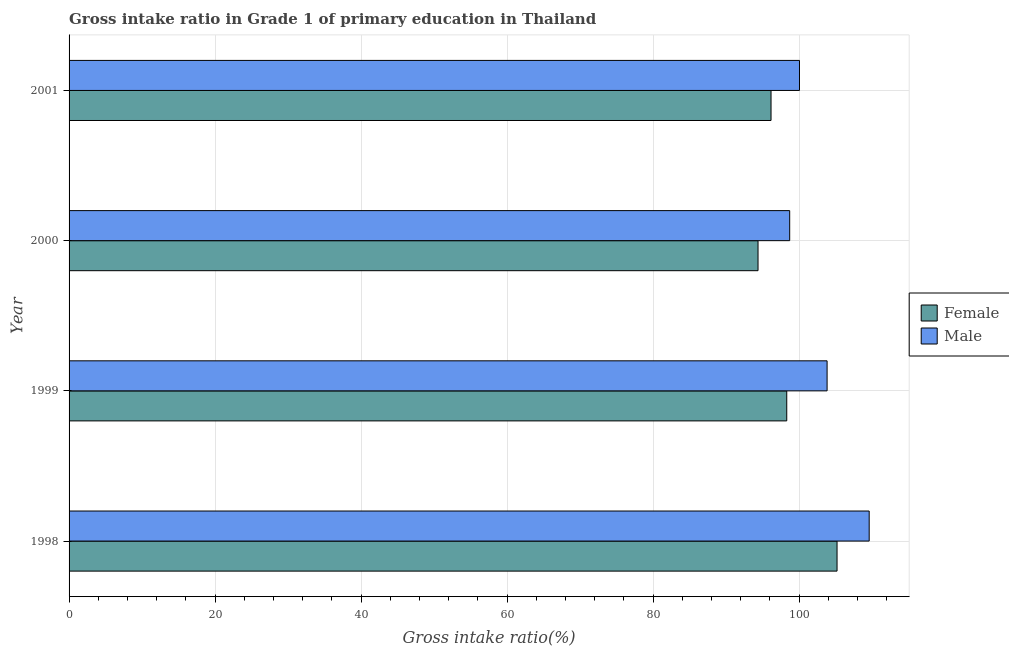How many different coloured bars are there?
Provide a short and direct response. 2. Are the number of bars per tick equal to the number of legend labels?
Your response must be concise. Yes. Are the number of bars on each tick of the Y-axis equal?
Your answer should be compact. Yes. How many bars are there on the 2nd tick from the top?
Provide a succinct answer. 2. What is the label of the 1st group of bars from the top?
Provide a short and direct response. 2001. In how many cases, is the number of bars for a given year not equal to the number of legend labels?
Offer a very short reply. 0. What is the gross intake ratio(female) in 1998?
Provide a short and direct response. 105.2. Across all years, what is the maximum gross intake ratio(male)?
Offer a very short reply. 109.61. Across all years, what is the minimum gross intake ratio(male)?
Provide a succinct answer. 98.71. In which year was the gross intake ratio(female) minimum?
Offer a very short reply. 2000. What is the total gross intake ratio(male) in the graph?
Ensure brevity in your answer.  412.21. What is the difference between the gross intake ratio(male) in 1999 and that in 2001?
Provide a succinct answer. 3.78. What is the difference between the gross intake ratio(male) in 2000 and the gross intake ratio(female) in 1998?
Provide a succinct answer. -6.49. What is the average gross intake ratio(female) per year?
Offer a terse response. 98.51. In the year 1998, what is the difference between the gross intake ratio(female) and gross intake ratio(male)?
Ensure brevity in your answer.  -4.4. In how many years, is the gross intake ratio(male) greater than 80 %?
Your answer should be very brief. 4. What is the ratio of the gross intake ratio(male) in 1999 to that in 2001?
Make the answer very short. 1.04. Is the gross intake ratio(male) in 1998 less than that in 1999?
Offer a very short reply. No. What is the difference between the highest and the second highest gross intake ratio(male)?
Your answer should be compact. 5.77. What is the difference between the highest and the lowest gross intake ratio(female)?
Give a very brief answer. 10.82. In how many years, is the gross intake ratio(male) greater than the average gross intake ratio(male) taken over all years?
Your answer should be very brief. 2. What does the 2nd bar from the top in 2001 represents?
Your answer should be very brief. Female. What does the 2nd bar from the bottom in 2001 represents?
Provide a succinct answer. Male. How many bars are there?
Your answer should be compact. 8. How many years are there in the graph?
Give a very brief answer. 4. Are the values on the major ticks of X-axis written in scientific E-notation?
Keep it short and to the point. No. Does the graph contain grids?
Provide a short and direct response. Yes. How many legend labels are there?
Offer a very short reply. 2. How are the legend labels stacked?
Give a very brief answer. Vertical. What is the title of the graph?
Give a very brief answer. Gross intake ratio in Grade 1 of primary education in Thailand. Does "Largest city" appear as one of the legend labels in the graph?
Offer a very short reply. No. What is the label or title of the X-axis?
Offer a terse response. Gross intake ratio(%). What is the Gross intake ratio(%) in Female in 1998?
Offer a very short reply. 105.2. What is the Gross intake ratio(%) of Male in 1998?
Your response must be concise. 109.61. What is the Gross intake ratio(%) in Female in 1999?
Keep it short and to the point. 98.31. What is the Gross intake ratio(%) in Male in 1999?
Your answer should be compact. 103.84. What is the Gross intake ratio(%) in Female in 2000?
Your answer should be compact. 94.38. What is the Gross intake ratio(%) in Male in 2000?
Make the answer very short. 98.71. What is the Gross intake ratio(%) in Female in 2001?
Offer a very short reply. 96.16. What is the Gross intake ratio(%) in Male in 2001?
Provide a short and direct response. 100.06. Across all years, what is the maximum Gross intake ratio(%) of Female?
Your response must be concise. 105.2. Across all years, what is the maximum Gross intake ratio(%) in Male?
Offer a very short reply. 109.61. Across all years, what is the minimum Gross intake ratio(%) of Female?
Give a very brief answer. 94.38. Across all years, what is the minimum Gross intake ratio(%) in Male?
Keep it short and to the point. 98.71. What is the total Gross intake ratio(%) of Female in the graph?
Provide a succinct answer. 394.05. What is the total Gross intake ratio(%) of Male in the graph?
Give a very brief answer. 412.21. What is the difference between the Gross intake ratio(%) of Female in 1998 and that in 1999?
Make the answer very short. 6.89. What is the difference between the Gross intake ratio(%) in Male in 1998 and that in 1999?
Provide a short and direct response. 5.77. What is the difference between the Gross intake ratio(%) in Female in 1998 and that in 2000?
Offer a very short reply. 10.82. What is the difference between the Gross intake ratio(%) in Male in 1998 and that in 2000?
Offer a very short reply. 10.89. What is the difference between the Gross intake ratio(%) of Female in 1998 and that in 2001?
Give a very brief answer. 9.04. What is the difference between the Gross intake ratio(%) in Male in 1998 and that in 2001?
Make the answer very short. 9.55. What is the difference between the Gross intake ratio(%) in Female in 1999 and that in 2000?
Your response must be concise. 3.93. What is the difference between the Gross intake ratio(%) in Male in 1999 and that in 2000?
Ensure brevity in your answer.  5.12. What is the difference between the Gross intake ratio(%) in Female in 1999 and that in 2001?
Your answer should be very brief. 2.15. What is the difference between the Gross intake ratio(%) in Male in 1999 and that in 2001?
Ensure brevity in your answer.  3.78. What is the difference between the Gross intake ratio(%) of Female in 2000 and that in 2001?
Your response must be concise. -1.78. What is the difference between the Gross intake ratio(%) in Male in 2000 and that in 2001?
Your response must be concise. -1.34. What is the difference between the Gross intake ratio(%) of Female in 1998 and the Gross intake ratio(%) of Male in 1999?
Ensure brevity in your answer.  1.36. What is the difference between the Gross intake ratio(%) of Female in 1998 and the Gross intake ratio(%) of Male in 2000?
Keep it short and to the point. 6.49. What is the difference between the Gross intake ratio(%) in Female in 1998 and the Gross intake ratio(%) in Male in 2001?
Make the answer very short. 5.15. What is the difference between the Gross intake ratio(%) in Female in 1999 and the Gross intake ratio(%) in Male in 2000?
Your answer should be very brief. -0.4. What is the difference between the Gross intake ratio(%) in Female in 1999 and the Gross intake ratio(%) in Male in 2001?
Offer a terse response. -1.74. What is the difference between the Gross intake ratio(%) in Female in 2000 and the Gross intake ratio(%) in Male in 2001?
Ensure brevity in your answer.  -5.68. What is the average Gross intake ratio(%) of Female per year?
Your answer should be compact. 98.51. What is the average Gross intake ratio(%) in Male per year?
Offer a terse response. 103.05. In the year 1998, what is the difference between the Gross intake ratio(%) of Female and Gross intake ratio(%) of Male?
Your answer should be very brief. -4.4. In the year 1999, what is the difference between the Gross intake ratio(%) in Female and Gross intake ratio(%) in Male?
Ensure brevity in your answer.  -5.53. In the year 2000, what is the difference between the Gross intake ratio(%) of Female and Gross intake ratio(%) of Male?
Ensure brevity in your answer.  -4.34. In the year 2001, what is the difference between the Gross intake ratio(%) in Female and Gross intake ratio(%) in Male?
Offer a terse response. -3.9. What is the ratio of the Gross intake ratio(%) of Female in 1998 to that in 1999?
Your response must be concise. 1.07. What is the ratio of the Gross intake ratio(%) of Male in 1998 to that in 1999?
Your response must be concise. 1.06. What is the ratio of the Gross intake ratio(%) of Female in 1998 to that in 2000?
Provide a short and direct response. 1.11. What is the ratio of the Gross intake ratio(%) of Male in 1998 to that in 2000?
Your answer should be very brief. 1.11. What is the ratio of the Gross intake ratio(%) in Female in 1998 to that in 2001?
Ensure brevity in your answer.  1.09. What is the ratio of the Gross intake ratio(%) in Male in 1998 to that in 2001?
Give a very brief answer. 1.1. What is the ratio of the Gross intake ratio(%) of Female in 1999 to that in 2000?
Your answer should be compact. 1.04. What is the ratio of the Gross intake ratio(%) of Male in 1999 to that in 2000?
Provide a short and direct response. 1.05. What is the ratio of the Gross intake ratio(%) of Female in 1999 to that in 2001?
Your answer should be very brief. 1.02. What is the ratio of the Gross intake ratio(%) of Male in 1999 to that in 2001?
Ensure brevity in your answer.  1.04. What is the ratio of the Gross intake ratio(%) of Female in 2000 to that in 2001?
Keep it short and to the point. 0.98. What is the ratio of the Gross intake ratio(%) of Male in 2000 to that in 2001?
Your answer should be compact. 0.99. What is the difference between the highest and the second highest Gross intake ratio(%) in Female?
Provide a succinct answer. 6.89. What is the difference between the highest and the second highest Gross intake ratio(%) of Male?
Keep it short and to the point. 5.77. What is the difference between the highest and the lowest Gross intake ratio(%) of Female?
Your response must be concise. 10.82. What is the difference between the highest and the lowest Gross intake ratio(%) of Male?
Your response must be concise. 10.89. 